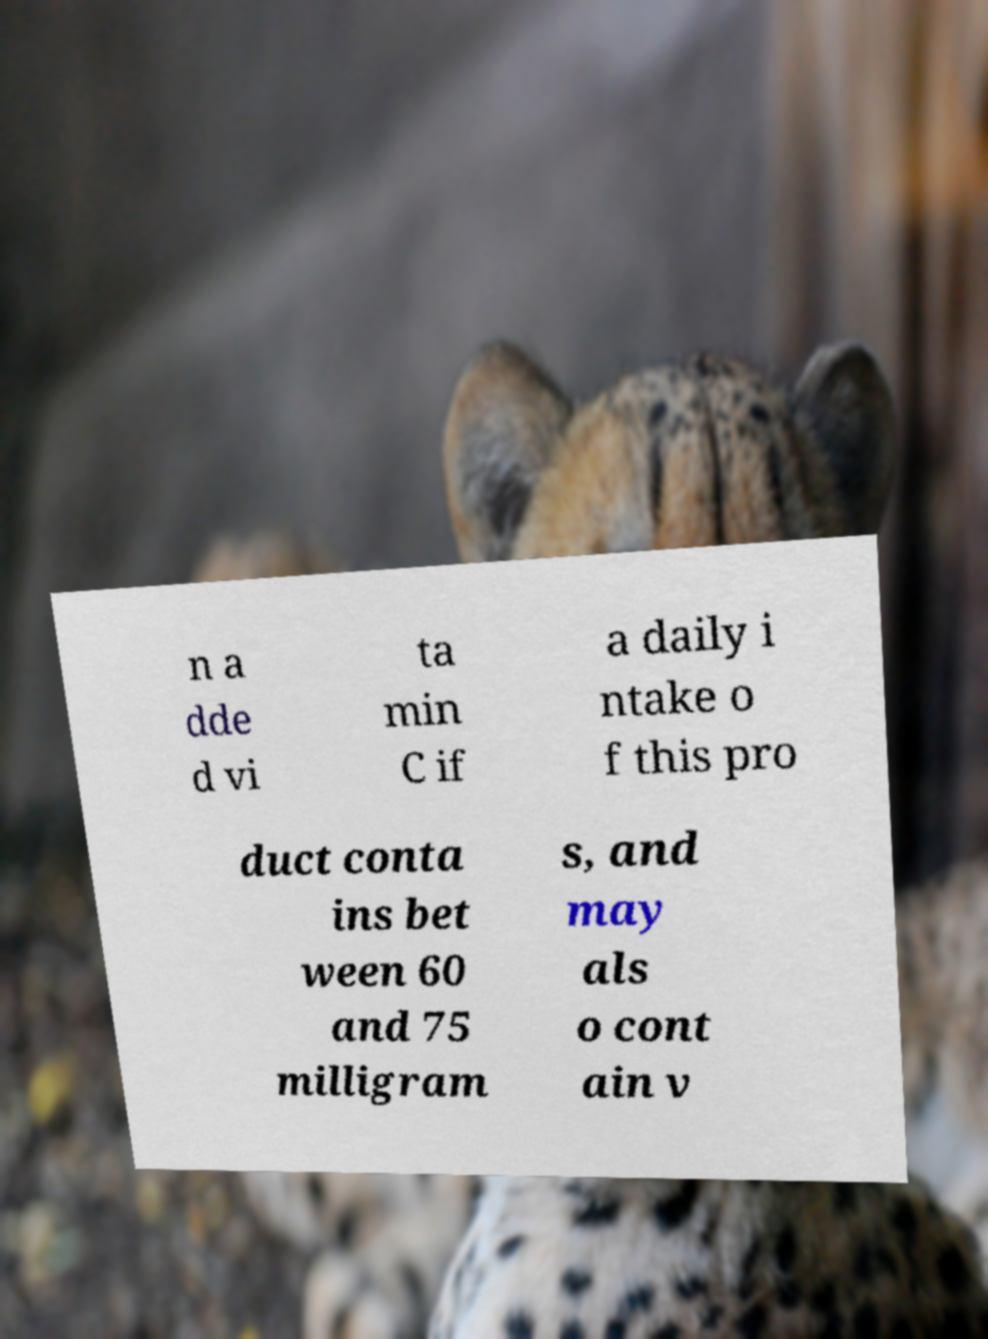Please read and relay the text visible in this image. What does it say? n a dde d vi ta min C if a daily i ntake o f this pro duct conta ins bet ween 60 and 75 milligram s, and may als o cont ain v 